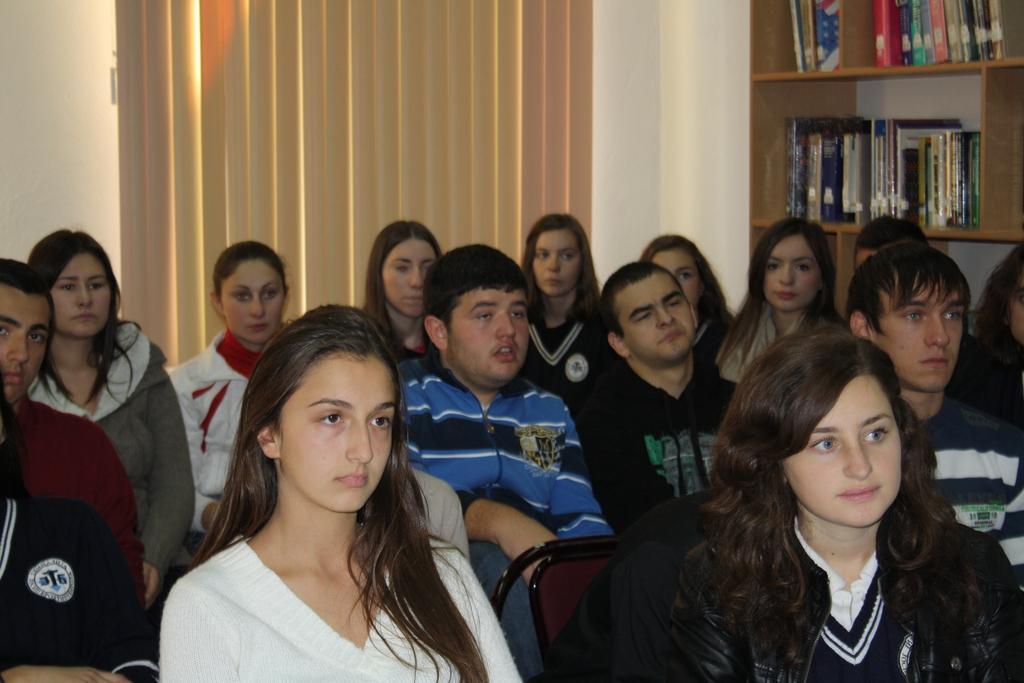Please provide a concise description of this image. In the foreground of this image, there are persons sitting on the chairs. In the background, there is a rack with books in it, a window blind and a wall. 